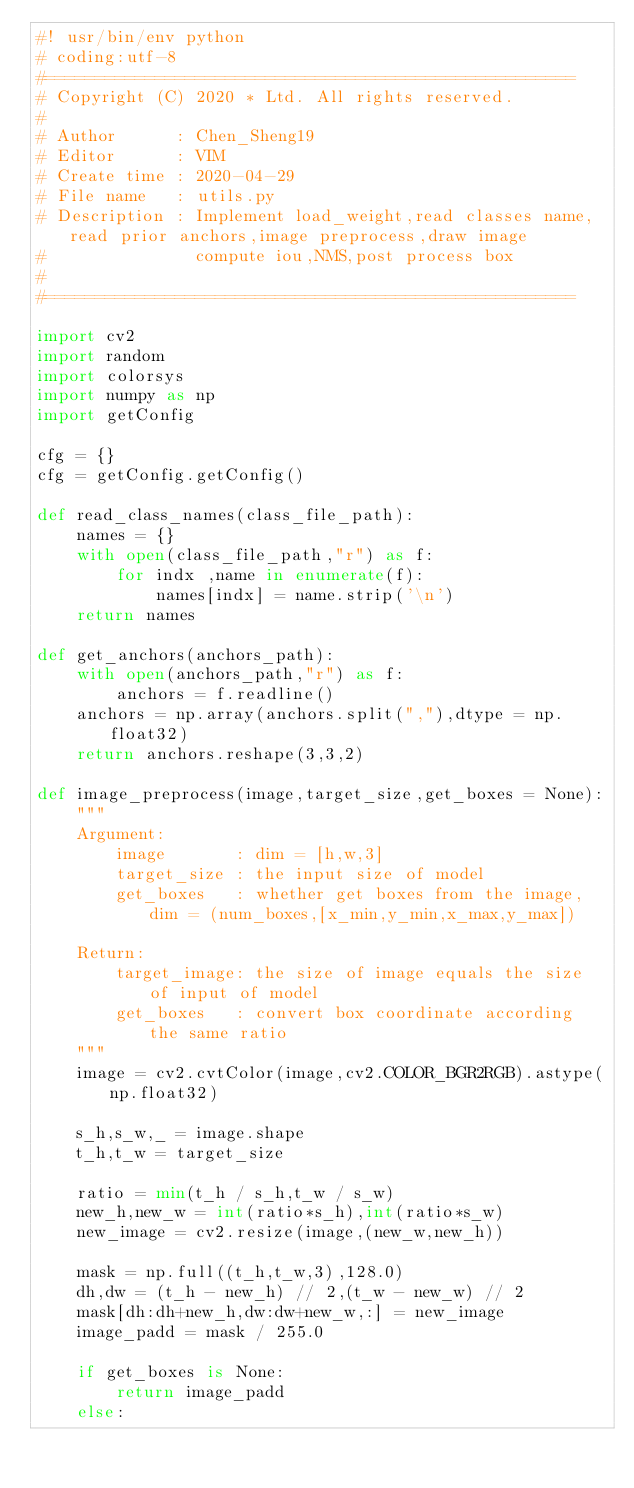Convert code to text. <code><loc_0><loc_0><loc_500><loc_500><_Python_>#! usr/bin/env python
# coding:utf-8
#=====================================================
# Copyright (C) 2020 * Ltd. All rights reserved.
#
# Author      : Chen_Sheng19
# Editor      : VIM
# Create time : 2020-04-29
# File name   : utils.py 
# Description : Implement load_weight,read classes name,read prior anchors,image preprocess,draw image
#               compute iou,NMS,post process box
#
#=====================================================

import cv2
import random
import colorsys
import numpy as np
import getConfig

cfg = {}
cfg = getConfig.getConfig()

def read_class_names(class_file_path):
    names = {}
    with open(class_file_path,"r") as f:
        for indx ,name in enumerate(f):
            names[indx] = name.strip('\n')
    return names

def get_anchors(anchors_path):
    with open(anchors_path,"r") as f:
        anchors = f.readline()
    anchors = np.array(anchors.split(","),dtype = np.float32)
    return anchors.reshape(3,3,2)

def image_preprocess(image,target_size,get_boxes = None):
    """
    Argument:
        image       : dim = [h,w,3]
        target_size : the input size of model
        get_boxes   : whether get boxes from the image,dim = (num_boxes,[x_min,y_min,x_max,y_max])

    Return:
        target_image: the size of image equals the size of input of model  
        get_boxes   : convert box coordinate according the same ratio
    """
    image = cv2.cvtColor(image,cv2.COLOR_BGR2RGB).astype(np.float32)

    s_h,s_w,_ = image.shape
    t_h,t_w = target_size

    ratio = min(t_h / s_h,t_w / s_w)
    new_h,new_w = int(ratio*s_h),int(ratio*s_w)
    new_image = cv2.resize(image,(new_w,new_h))

    mask = np.full((t_h,t_w,3),128.0)
    dh,dw = (t_h - new_h) // 2,(t_w - new_w) // 2
    mask[dh:dh+new_h,dw:dw+new_w,:] = new_image
    image_padd = mask / 255.0

    if get_boxes is None:
        return image_padd
    else:</code> 